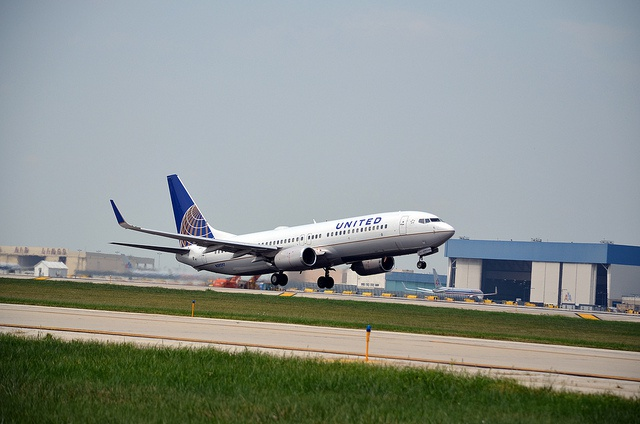Describe the objects in this image and their specific colors. I can see a airplane in gray, lightgray, black, and darkgray tones in this image. 